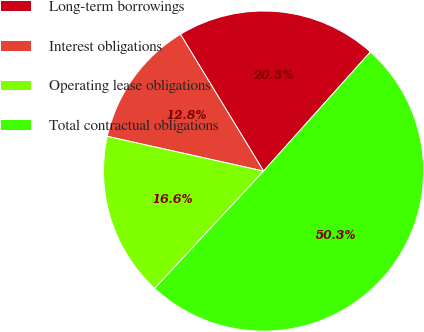<chart> <loc_0><loc_0><loc_500><loc_500><pie_chart><fcel>Long-term borrowings<fcel>Interest obligations<fcel>Operating lease obligations<fcel>Total contractual obligations<nl><fcel>20.32%<fcel>12.83%<fcel>16.57%<fcel>50.28%<nl></chart> 